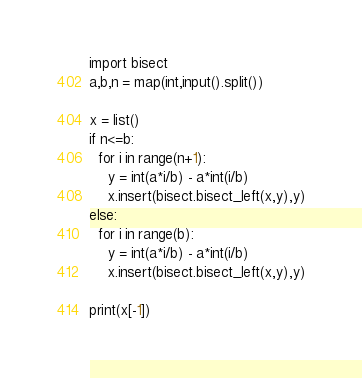<code> <loc_0><loc_0><loc_500><loc_500><_Python_>import bisect
a,b,n = map(int,input().split())

x = list()
if n<=b:
  for i in range(n+1):
    y = int(a*i/b) - a*int(i/b)
    x.insert(bisect.bisect_left(x,y),y)
else:
  for i in range(b):
    y = int(a*i/b) - a*int(i/b)
    x.insert(bisect.bisect_left(x,y),y)

print(x[-1])
</code> 